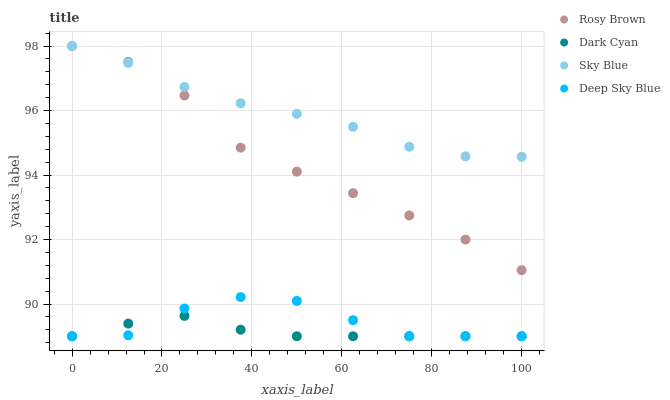Does Dark Cyan have the minimum area under the curve?
Answer yes or no. Yes. Does Sky Blue have the maximum area under the curve?
Answer yes or no. Yes. Does Rosy Brown have the minimum area under the curve?
Answer yes or no. No. Does Rosy Brown have the maximum area under the curve?
Answer yes or no. No. Is Dark Cyan the smoothest?
Answer yes or no. Yes. Is Deep Sky Blue the roughest?
Answer yes or no. Yes. Is Sky Blue the smoothest?
Answer yes or no. No. Is Sky Blue the roughest?
Answer yes or no. No. Does Dark Cyan have the lowest value?
Answer yes or no. Yes. Does Rosy Brown have the lowest value?
Answer yes or no. No. Does Rosy Brown have the highest value?
Answer yes or no. Yes. Does Deep Sky Blue have the highest value?
Answer yes or no. No. Is Dark Cyan less than Rosy Brown?
Answer yes or no. Yes. Is Rosy Brown greater than Deep Sky Blue?
Answer yes or no. Yes. Does Deep Sky Blue intersect Dark Cyan?
Answer yes or no. Yes. Is Deep Sky Blue less than Dark Cyan?
Answer yes or no. No. Is Deep Sky Blue greater than Dark Cyan?
Answer yes or no. No. Does Dark Cyan intersect Rosy Brown?
Answer yes or no. No. 